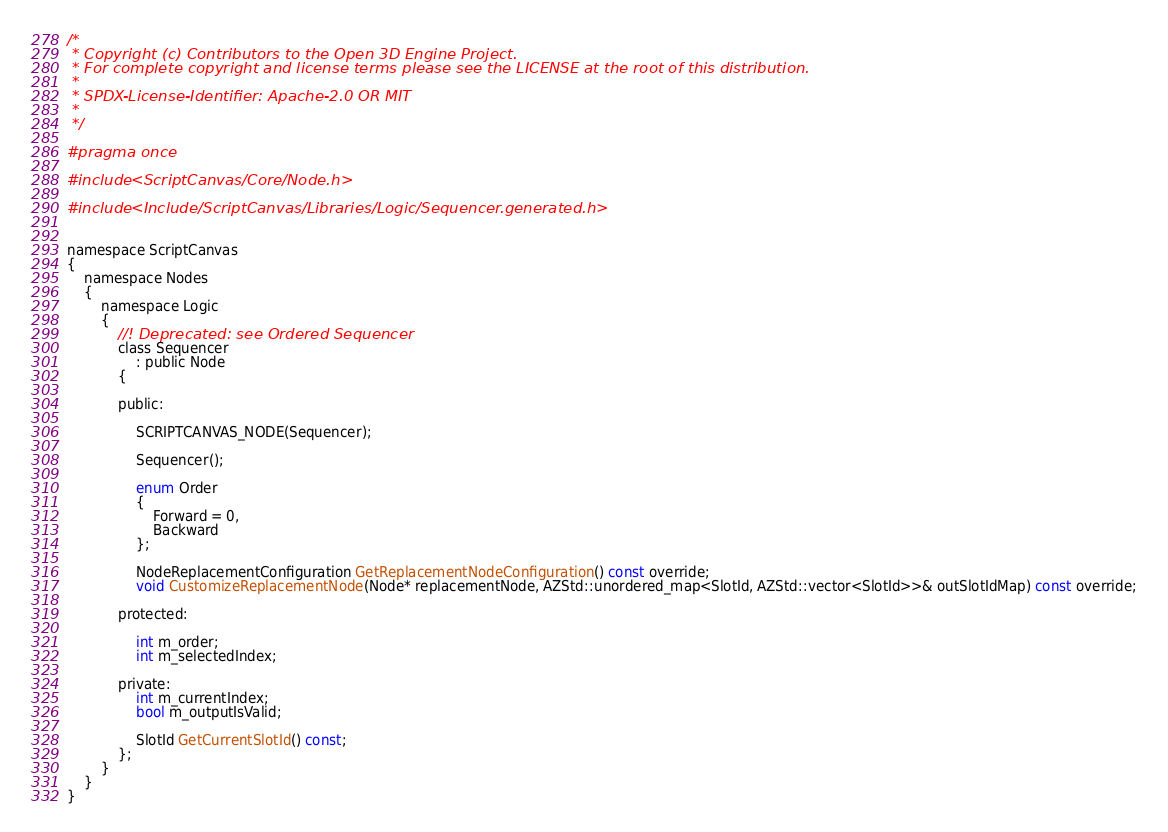<code> <loc_0><loc_0><loc_500><loc_500><_C_>/*
 * Copyright (c) Contributors to the Open 3D Engine Project.
 * For complete copyright and license terms please see the LICENSE at the root of this distribution.
 *
 * SPDX-License-Identifier: Apache-2.0 OR MIT
 *
 */

#pragma once

#include <ScriptCanvas/Core/Node.h>

#include <Include/ScriptCanvas/Libraries/Logic/Sequencer.generated.h>


namespace ScriptCanvas
{
    namespace Nodes
    {
        namespace Logic
        {
            //! Deprecated: see Ordered Sequencer
            class Sequencer
                : public Node
            {

            public:

                SCRIPTCANVAS_NODE(Sequencer);

                Sequencer();

                enum Order
                {
                    Forward = 0,
                    Backward
                };

                NodeReplacementConfiguration GetReplacementNodeConfiguration() const override;
                void CustomizeReplacementNode(Node* replacementNode, AZStd::unordered_map<SlotId, AZStd::vector<SlotId>>& outSlotIdMap) const override;

            protected:

                int m_order;
                int m_selectedIndex;

            private:
                int m_currentIndex;
                bool m_outputIsValid;

                SlotId GetCurrentSlotId() const;
            };
        }
    }
}
</code> 